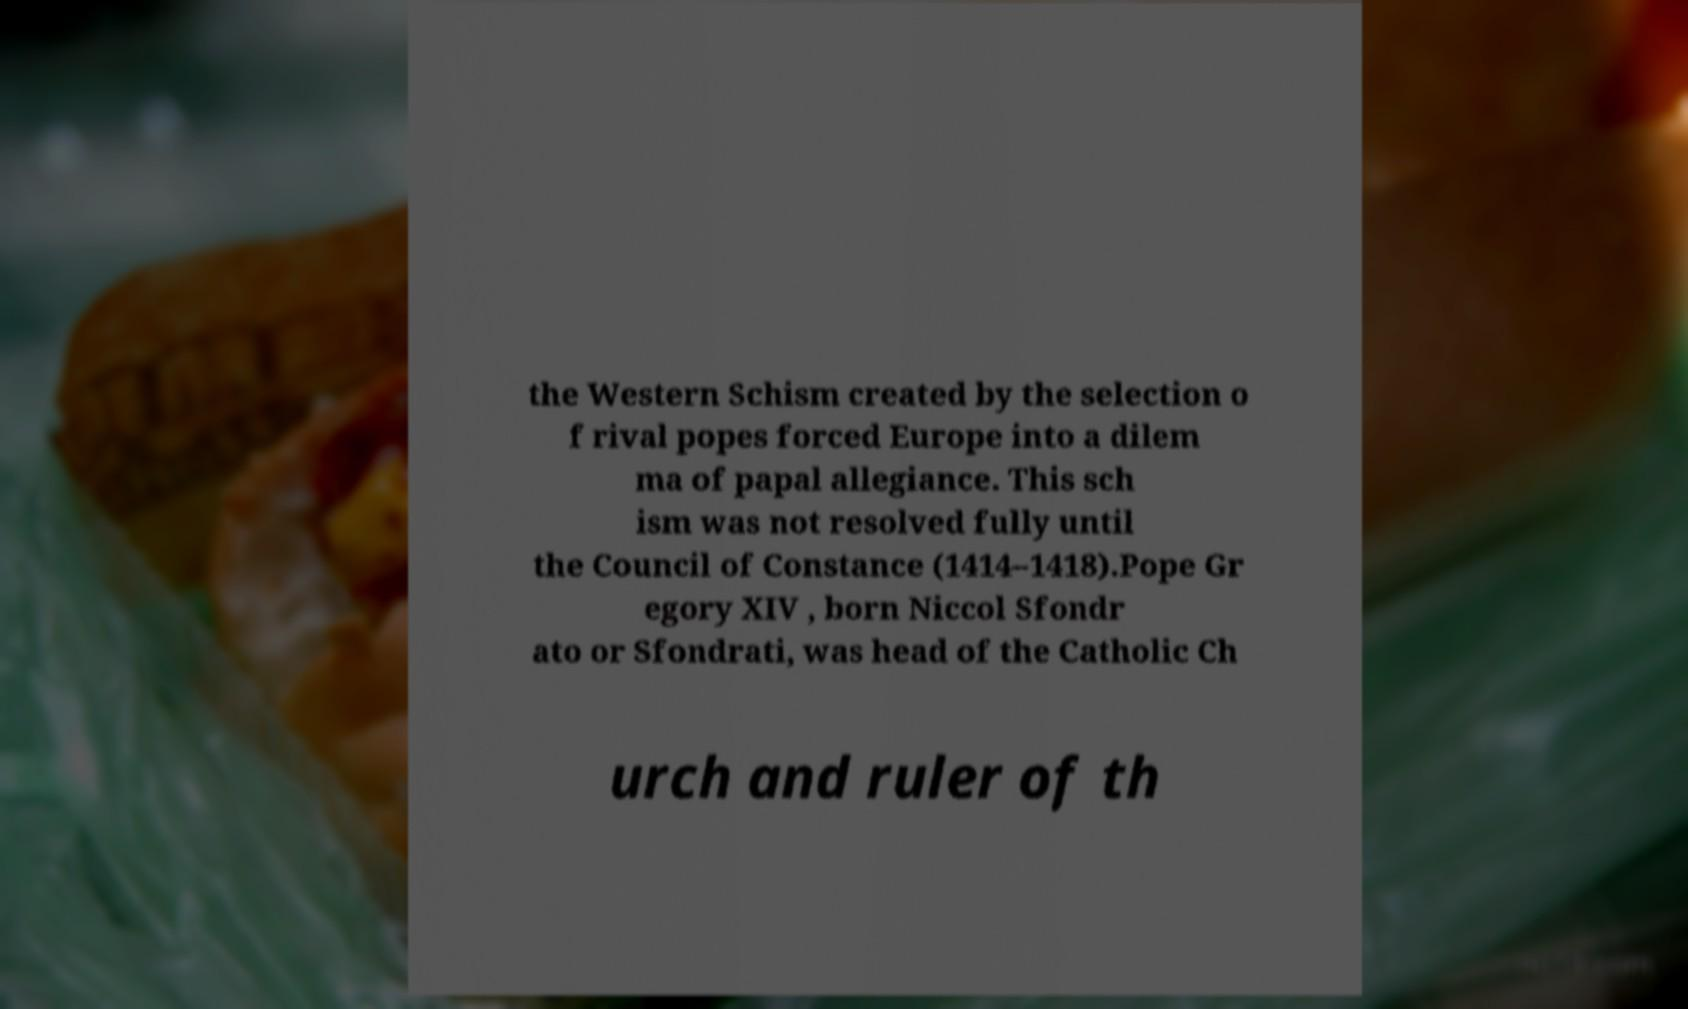For documentation purposes, I need the text within this image transcribed. Could you provide that? the Western Schism created by the selection o f rival popes forced Europe into a dilem ma of papal allegiance. This sch ism was not resolved fully until the Council of Constance (1414–1418).Pope Gr egory XIV , born Niccol Sfondr ato or Sfondrati, was head of the Catholic Ch urch and ruler of th 